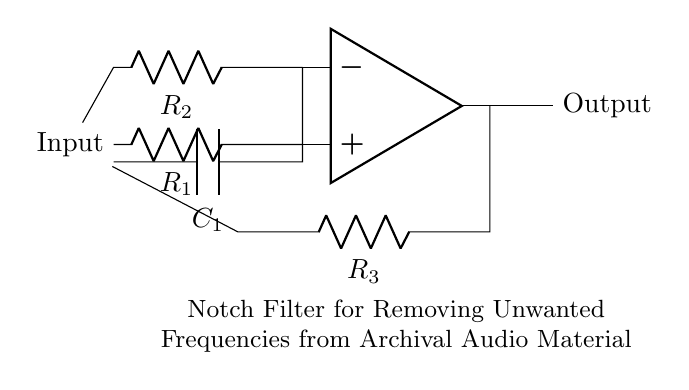What type of circuit is this? This circuit is a notch filter. A notch filter is specifically designed to attenuate (reduce) the amplitude of a narrow band of frequencies while allowing the remaining frequencies to pass through.
Answer: notch filter What are the components used in this circuit? The circuit consists of resistors and a capacitor. The resistors are labeled as R1, R2, and R3, and there is one capacitor labeled as C1. Components specifically serve functions that together create a notch filter effect.
Answer: resistors and a capacitor What is the function of the op-amp in this circuit? The operational amplifier (op-amp) amplifies the input signal after it has been processed by the resistors and capacitor. It is crucial for creating the desired signal response of the notch filter, and it ensures that the output can be properly scaled.
Answer: amplification Which resistor is connected to the output? The resistor R3 is connected to the output of the op-amp. This connection helps control the output signal characteristics and maintains the filter response required for eliminating unwanted frequencies.
Answer: R3 What is the purpose of capacitor C1 in this circuit? Capacitor C1 is used to provide a path for AC signals while blocking DC signals, which is essential in filtering out specific unwanted frequencies from the audio material. The capacitor works together with the resistors to form the notch filter characteristic.
Answer: filter unwanted frequencies Why are multiple resistors used in this circuit? Multiple resistors R1, R2, and R3 are used to establish the gain and to create the feedback necessary for the op-amp to function correctly. Different resistor values can affect the frequency response and selectivity of the notch filter, balancing the filter characteristics to achieve the desired notch frequency.
Answer: gain and feedback 